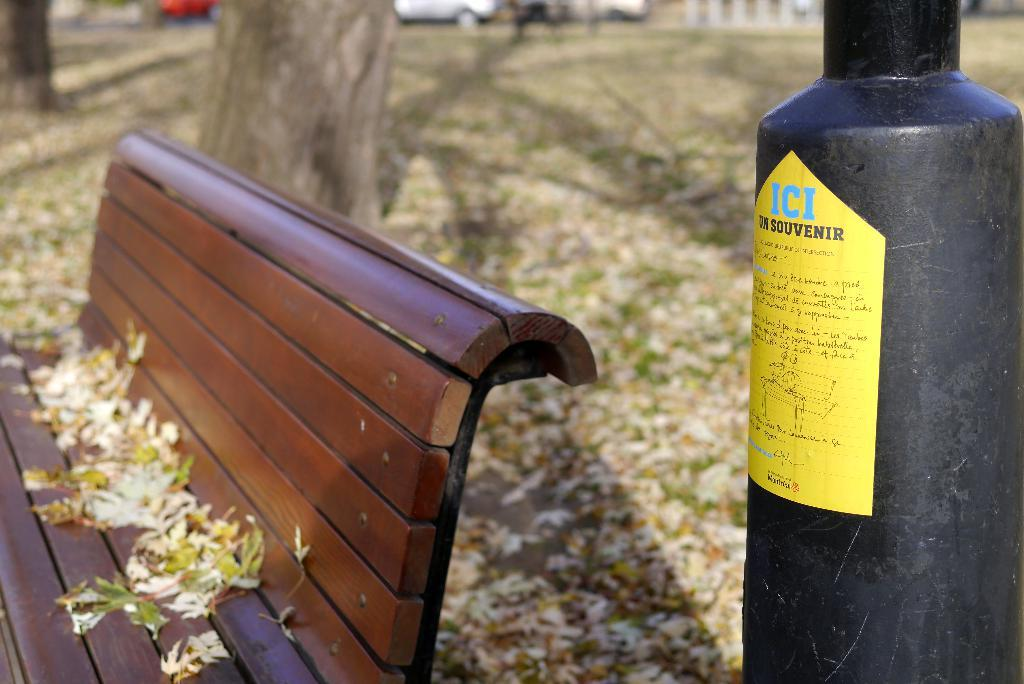What object is located beside the bench in the image? There is a metal rod beside the bench in the image. What decorative items can be seen on the bench? There are flowers on the bench. What can be seen in the distance behind the bench? There are trees and vehicles visible in the background of the image. How many pizzas are being delivered to the bench in the image? There are no pizzas or delivery in the image; it only features a bench, a metal rod, flowers, trees, and vehicles in the background. 